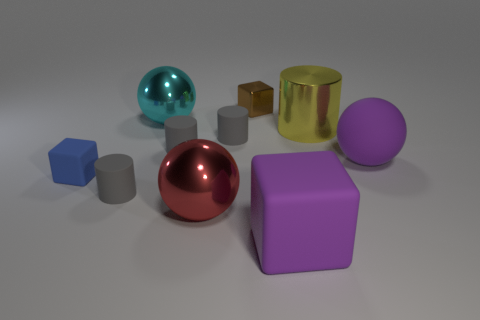How many gray cylinders must be subtracted to get 1 gray cylinders? 2 Subtract all green spheres. How many gray cylinders are left? 3 Subtract all red spheres. Subtract all cyan blocks. How many spheres are left? 2 Subtract all cylinders. How many objects are left? 6 Subtract all small green things. Subtract all tiny cylinders. How many objects are left? 7 Add 8 small brown metal things. How many small brown metal things are left? 9 Add 4 green matte blocks. How many green matte blocks exist? 4 Subtract 0 brown balls. How many objects are left? 10 